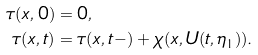<formula> <loc_0><loc_0><loc_500><loc_500>\tau ( x , 0 ) & = 0 , \\ \tau ( x , t ) & = \tau ( x , t - ) + \chi ( x , U ( t , \eta _ { 1 } ) ) .</formula> 